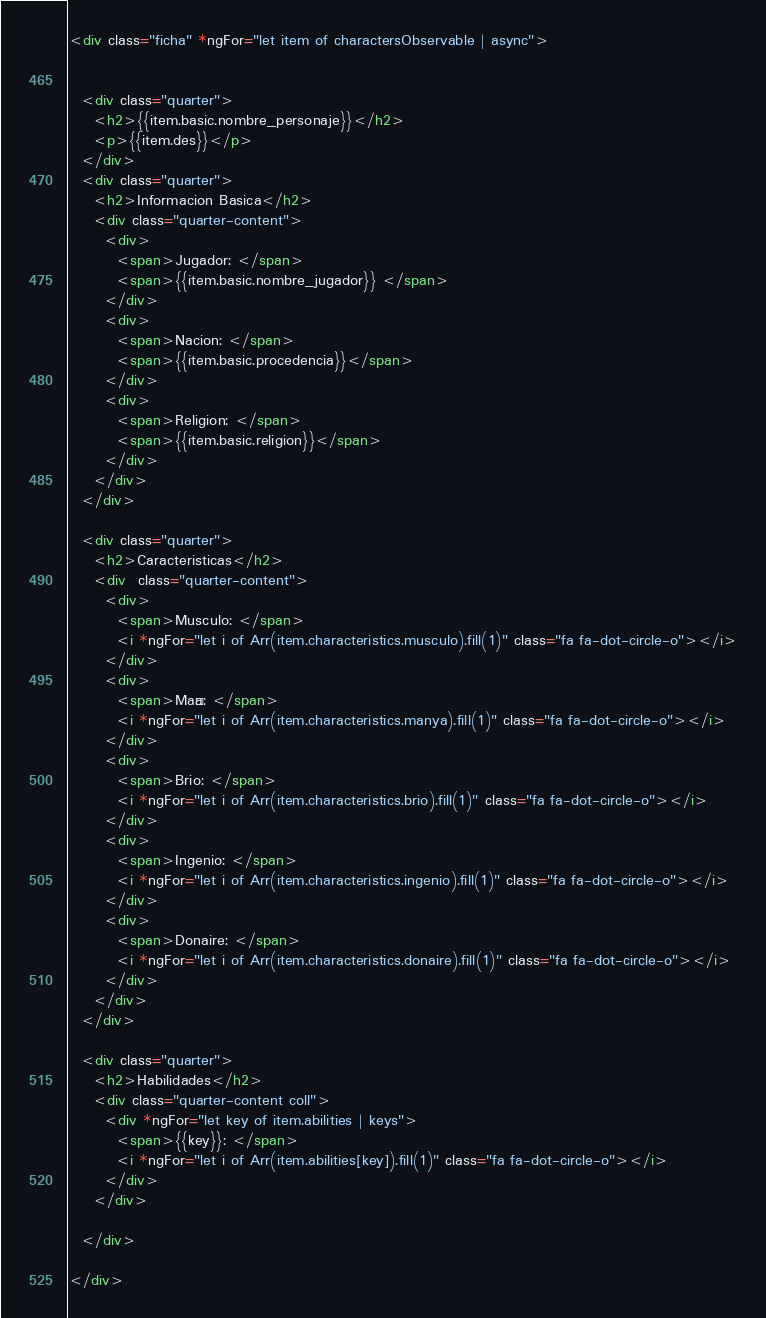<code> <loc_0><loc_0><loc_500><loc_500><_HTML_><div class="ficha" *ngFor="let item of charactersObservable | async">


  <div class="quarter">
    <h2>{{item.basic.nombre_personaje}}</h2>
    <p>{{item.des}}</p>
  </div>
  <div class="quarter">
    <h2>Informacion Basica</h2>
    <div class="quarter-content">
      <div>
        <span>Jugador: </span>
        <span>{{item.basic.nombre_jugador}} </span>
      </div>
      <div>
        <span>Nacion: </span>
        <span>{{item.basic.procedencia}}</span>
      </div>
      <div>
        <span>Religion: </span>
        <span>{{item.basic.religion}}</span>
      </div>
    </div>
  </div>

  <div class="quarter">
    <h2>Caracteristicas</h2>
    <div  class="quarter-content">
      <div>
        <span>Musculo: </span>
        <i *ngFor="let i of Arr(item.characteristics.musculo).fill(1)" class="fa fa-dot-circle-o"></i>
      </div>
      <div>
        <span>Maña: </span>
        <i *ngFor="let i of Arr(item.characteristics.manya).fill(1)" class="fa fa-dot-circle-o"></i>
      </div>
      <div>
        <span>Brio: </span>
        <i *ngFor="let i of Arr(item.characteristics.brio).fill(1)" class="fa fa-dot-circle-o"></i>
      </div>
      <div>
        <span>Ingenio: </span>
        <i *ngFor="let i of Arr(item.characteristics.ingenio).fill(1)" class="fa fa-dot-circle-o"></i>
      </div>
      <div>
        <span>Donaire: </span>
        <i *ngFor="let i of Arr(item.characteristics.donaire).fill(1)" class="fa fa-dot-circle-o"></i>
      </div>
    </div>
  </div>

  <div class="quarter">
    <h2>Habilidades</h2>
    <div class="quarter-content coll">
      <div *ngFor="let key of item.abilities | keys">
        <span>{{key}}: </span>
        <i *ngFor="let i of Arr(item.abilities[key]).fill(1)" class="fa fa-dot-circle-o"></i>
      </div>
    </div>

  </div>

</div>
</code> 